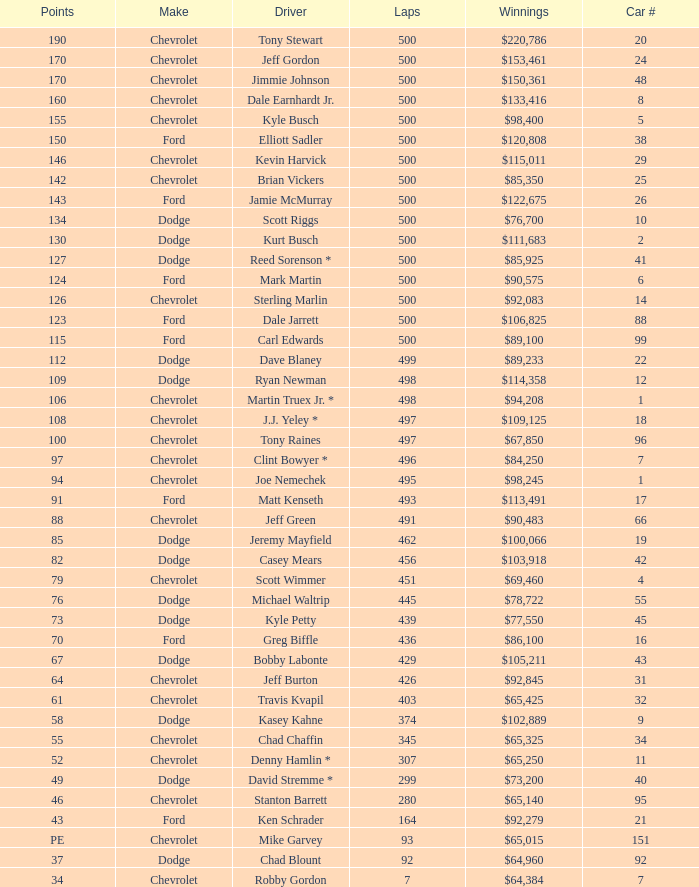What is the average car number of all the drivers with 109 points? 12.0. 